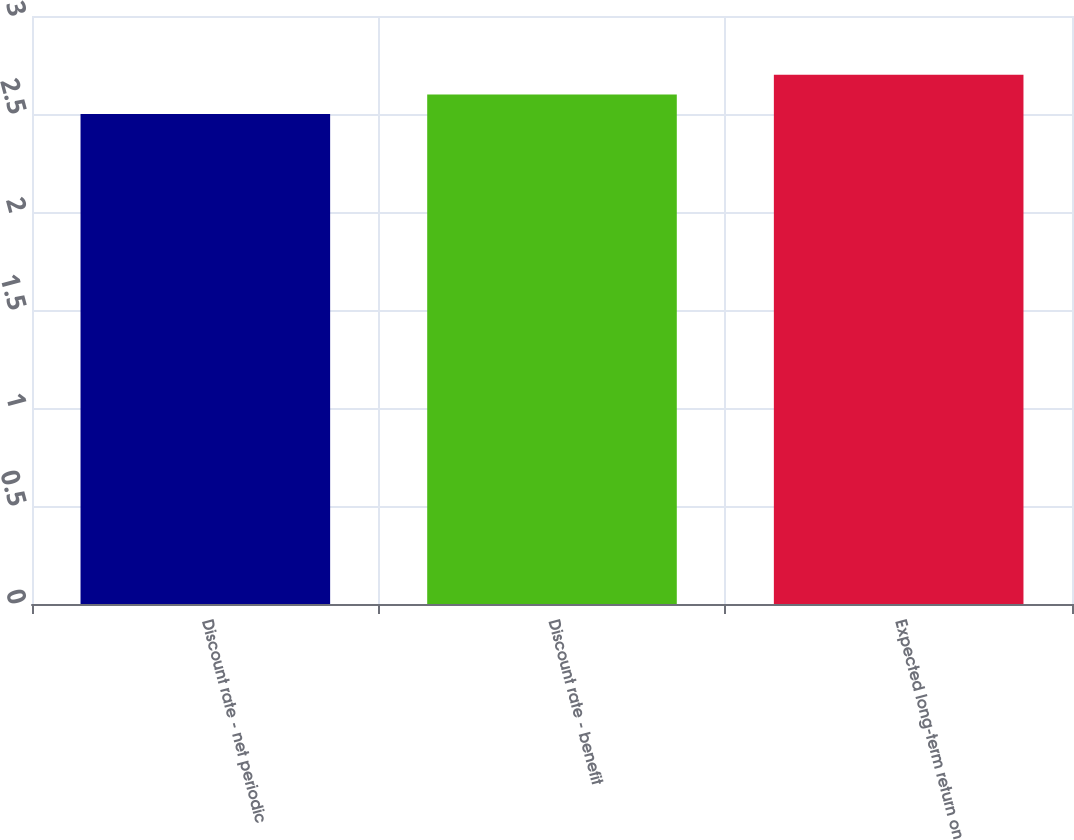<chart> <loc_0><loc_0><loc_500><loc_500><bar_chart><fcel>Discount rate - net periodic<fcel>Discount rate - benefit<fcel>Expected long-term return on<nl><fcel>2.5<fcel>2.6<fcel>2.7<nl></chart> 